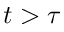Convert formula to latex. <formula><loc_0><loc_0><loc_500><loc_500>t > \tau</formula> 